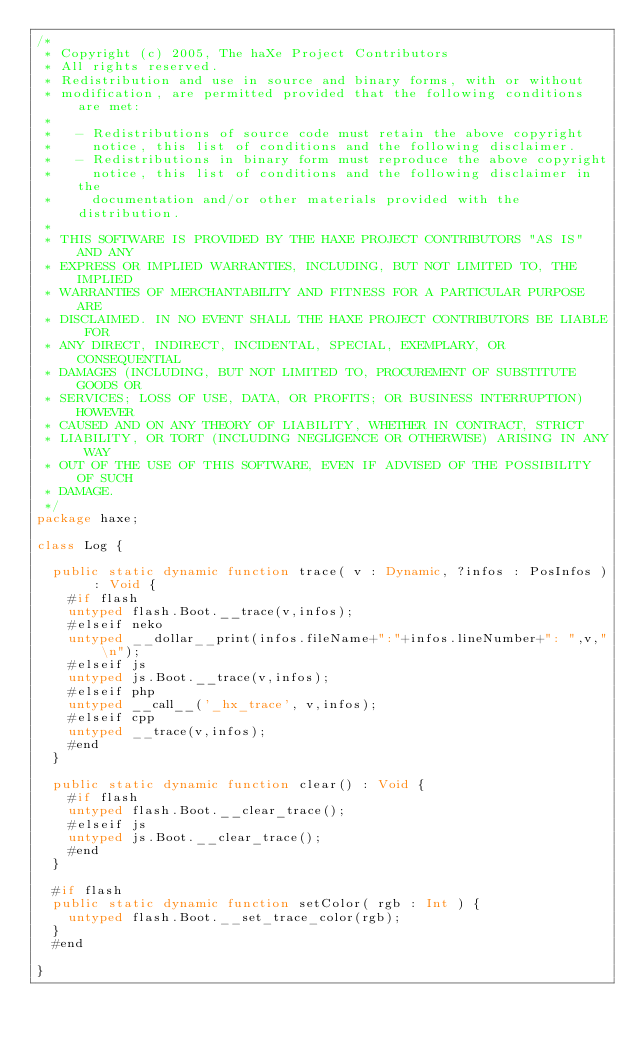Convert code to text. <code><loc_0><loc_0><loc_500><loc_500><_Haxe_>/*
 * Copyright (c) 2005, The haXe Project Contributors
 * All rights reserved.
 * Redistribution and use in source and binary forms, with or without
 * modification, are permitted provided that the following conditions are met:
 *
 *   - Redistributions of source code must retain the above copyright
 *     notice, this list of conditions and the following disclaimer.
 *   - Redistributions in binary form must reproduce the above copyright
 *     notice, this list of conditions and the following disclaimer in the
 *     documentation and/or other materials provided with the distribution.
 *
 * THIS SOFTWARE IS PROVIDED BY THE HAXE PROJECT CONTRIBUTORS "AS IS" AND ANY
 * EXPRESS OR IMPLIED WARRANTIES, INCLUDING, BUT NOT LIMITED TO, THE IMPLIED
 * WARRANTIES OF MERCHANTABILITY AND FITNESS FOR A PARTICULAR PURPOSE ARE
 * DISCLAIMED. IN NO EVENT SHALL THE HAXE PROJECT CONTRIBUTORS BE LIABLE FOR
 * ANY DIRECT, INDIRECT, INCIDENTAL, SPECIAL, EXEMPLARY, OR CONSEQUENTIAL
 * DAMAGES (INCLUDING, BUT NOT LIMITED TO, PROCUREMENT OF SUBSTITUTE GOODS OR
 * SERVICES; LOSS OF USE, DATA, OR PROFITS; OR BUSINESS INTERRUPTION) HOWEVER
 * CAUSED AND ON ANY THEORY OF LIABILITY, WHETHER IN CONTRACT, STRICT
 * LIABILITY, OR TORT (INCLUDING NEGLIGENCE OR OTHERWISE) ARISING IN ANY WAY
 * OUT OF THE USE OF THIS SOFTWARE, EVEN IF ADVISED OF THE POSSIBILITY OF SUCH
 * DAMAGE.
 */
package haxe;

class Log {

	public static dynamic function trace( v : Dynamic, ?infos : PosInfos ) : Void {
		#if flash
		untyped flash.Boot.__trace(v,infos);
		#elseif neko
		untyped __dollar__print(infos.fileName+":"+infos.lineNumber+": ",v,"\n");
		#elseif js
		untyped js.Boot.__trace(v,infos);
		#elseif php
		untyped __call__('_hx_trace', v,infos);
		#elseif cpp
		untyped __trace(v,infos);
		#end
	}

	public static dynamic function clear() : Void {
		#if flash
		untyped flash.Boot.__clear_trace();
		#elseif js
		untyped js.Boot.__clear_trace();
		#end
	}

	#if flash
	public static dynamic function setColor( rgb : Int ) {
		untyped flash.Boot.__set_trace_color(rgb);
	}
	#end

}
</code> 